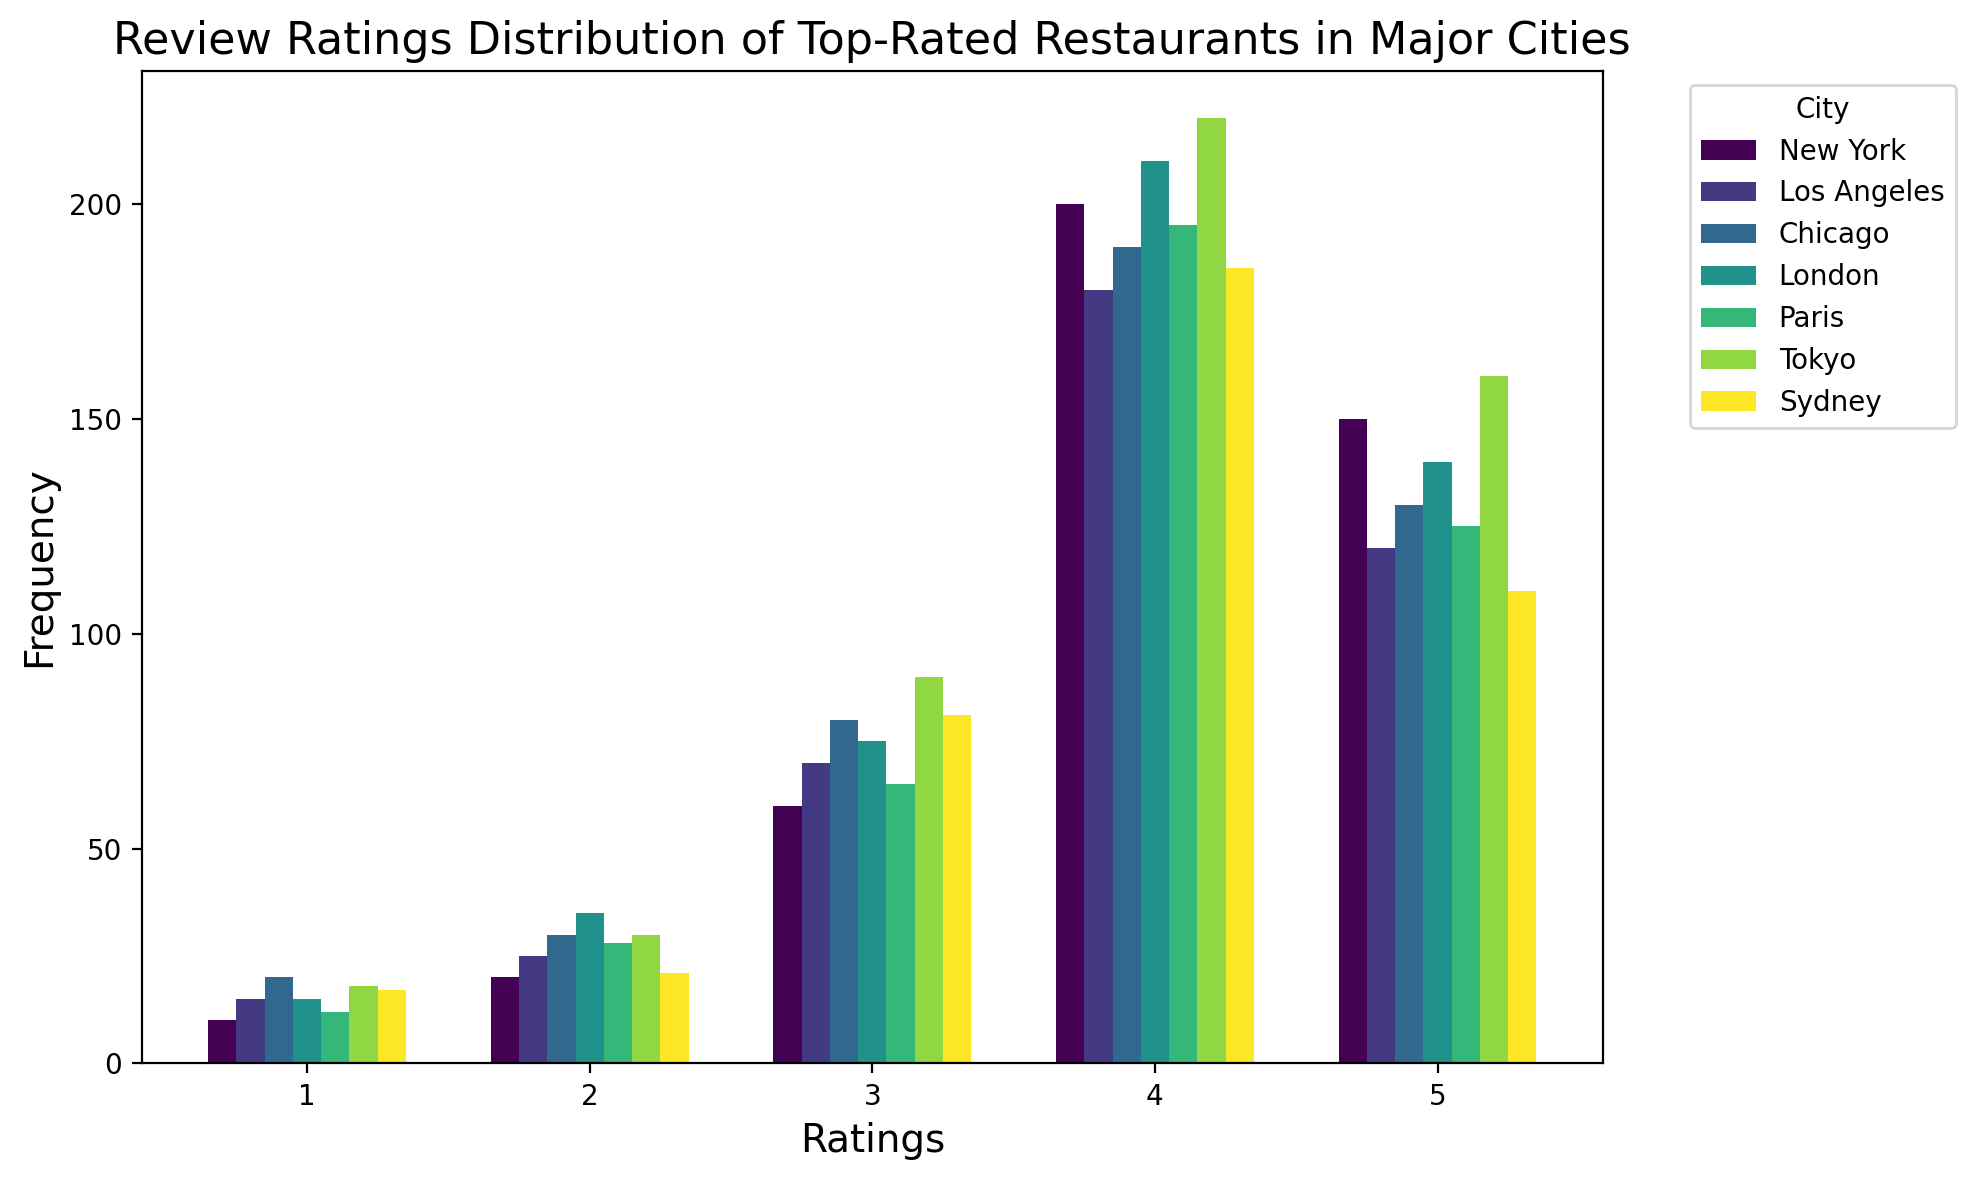Which city has the highest frequency of 5-star ratings? Look at the heights of the bars for 5-star ratings for each city. Tokyo has the highest bar for 5-star ratings.
Answer: Tokyo How does the frequency of 4-star ratings in New York compare to Los Angeles? Compare the heights of the bars for 4-star ratings for both cities. New York has 200, and Los Angeles has 180.
Answer: New York has higher What's the total frequency of 3-star ratings in Tokyo and Paris? Add the frequencies of 3-star ratings for Tokyo (90) and Paris (65).
Answer: 155 Which city has the lowest frequency of 1-star ratings? Look for the shortest bar in the 1-star rating category. New York has the shortest bar for 1-star ratings.
Answer: New York Is the frequency of 2-star ratings in Sydney greater than or less than 20? Look at the height of the bar for 2-star ratings in Sydney. Sydney shows 21 for 2-star ratings.
Answer: Greater than Which city has a higher frequency of 4-star ratings, Chicago or London? Compare the heights of the bars for 4-star ratings in both cities. Chicago has 190, and London has 210.
Answer: London How much higher is the frequency of 5-star ratings in Tokyo compared to Sydney? Subtract the frequency of 5-star ratings in Sydney (110) from that in Tokyo (160).
Answer: 50 What is the mode rating in New York? The mode is the rating with the highest frequency. In New York, the highest bar is for 4-star ratings with a frequency of 200.
Answer: 4 Is the frequency of 3-star ratings in any city greater than 100? Check if any of the bars for 3-star ratings exceed 100. None of the 3-star bars reaches 100.
Answer: No Among all cities, which one has the most consistent/fewest variation in rating frequencies? Identify the city with the most even bar heights across different ratings. New York has a relatively more varied frequency, while Sydney has visually even bar heights.
Answer: Sydney 